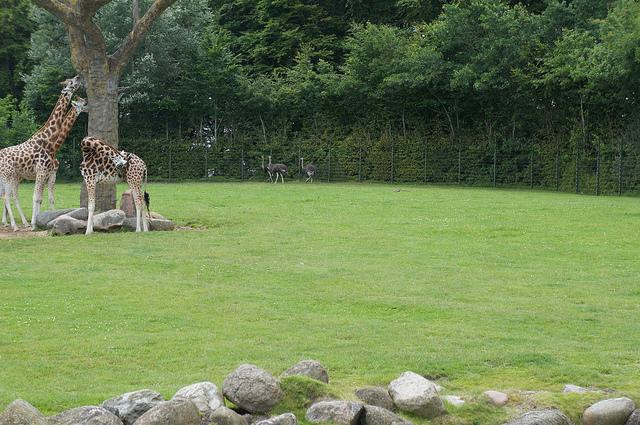The pattern on this animal most closely resembles the pattern on what other animal? leopard 